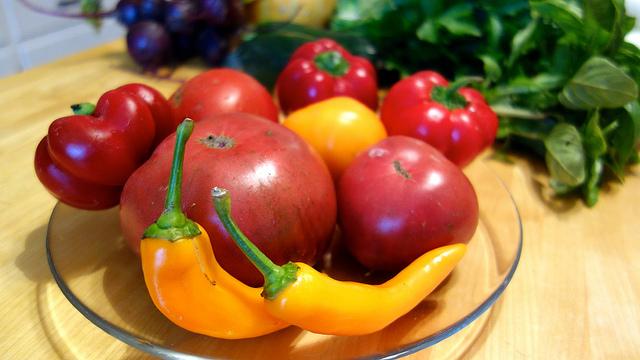What is the thinnest veggie shown?
Quick response, please. Pepper. Are they ripe enough to eat?
Concise answer only. Yes. What colors are the veggies on the plate?
Concise answer only. Red and yellow. 